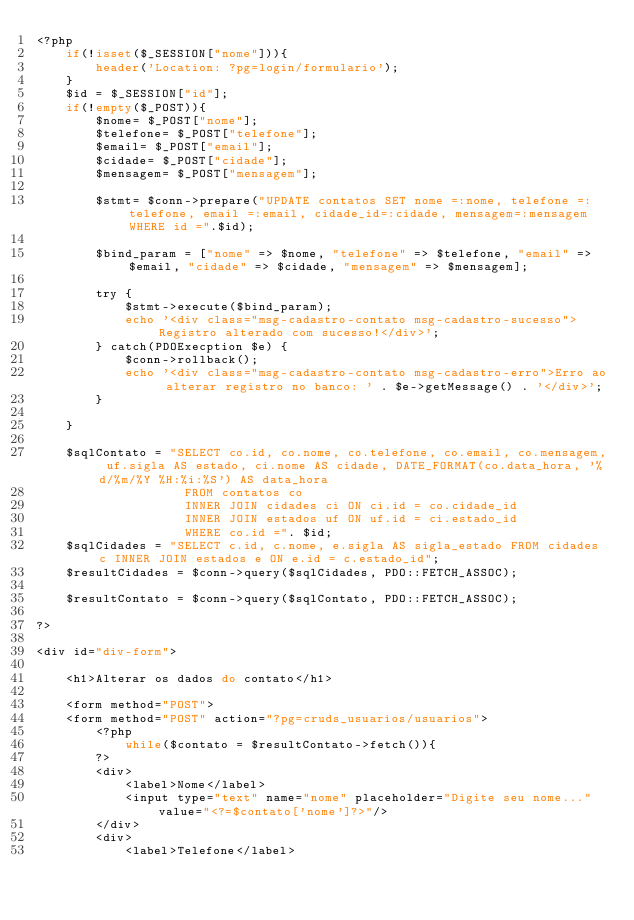<code> <loc_0><loc_0><loc_500><loc_500><_PHP_><?php
    if(!isset($_SESSION["nome"])){
        header('Location: ?pg=login/formulario');
    }
    $id = $_SESSION["id"];
    if(!empty($_POST)){        
        $nome= $_POST["nome"];
        $telefone= $_POST["telefone"];
        $email= $_POST["email"];
        $cidade= $_POST["cidade"];
        $mensagem= $_POST["mensagem"];    
        
        $stmt= $conn->prepare("UPDATE contatos SET nome =:nome, telefone =:telefone, email =:email, cidade_id=:cidade, mensagem=:mensagem WHERE id =".$id);
        
        $bind_param = ["nome" => $nome, "telefone" => $telefone, "email" => $email, "cidade" => $cidade, "mensagem" => $mensagem];
        
        try {            
            $stmt->execute($bind_param);
            echo '<div class="msg-cadastro-contato msg-cadastro-sucesso">Registro alterado com sucesso!</div>';
        } catch(PDOExecption $e) {
            $conn->rollback();
            echo '<div class="msg-cadastro-contato msg-cadastro-erro">Erro ao alterar registro no banco: ' . $e->getMessage() . '</div>';
        }
    
    }

    $sqlContato = "SELECT co.id, co.nome, co.telefone, co.email, co.mensagem, uf.sigla AS estado, ci.nome AS cidade, DATE_FORMAT(co.data_hora, '%d/%m/%Y %H:%i:%S') AS data_hora
                    FROM contatos co 
                    INNER JOIN cidades ci ON ci.id = co.cidade_id 
                    INNER JOIN estados uf ON uf.id = ci.estado_id
                    WHERE co.id =". $id;
    $sqlCidades = "SELECT c.id, c.nome, e.sigla AS sigla_estado FROM cidades c INNER JOIN estados e ON e.id = c.estado_id";
    $resultCidades = $conn->query($sqlCidades, PDO::FETCH_ASSOC);
    
    $resultContato = $conn->query($sqlContato, PDO::FETCH_ASSOC);
    
?>

<div id="div-form">
    
    <h1>Alterar os dados do contato</h1>

    <form method="POST">
    <form method="POST" action="?pg=cruds_usuarios/usuarios">
        <?php 
            while($contato = $resultContato->fetch()){                
        ?>
        <div>
            <label>Nome</label>
            <input type="text" name="nome" placeholder="Digite seu nome..." value="<?=$contato['nome']?>"/>
        </div>
        <div>
            <label>Telefone</label></code> 